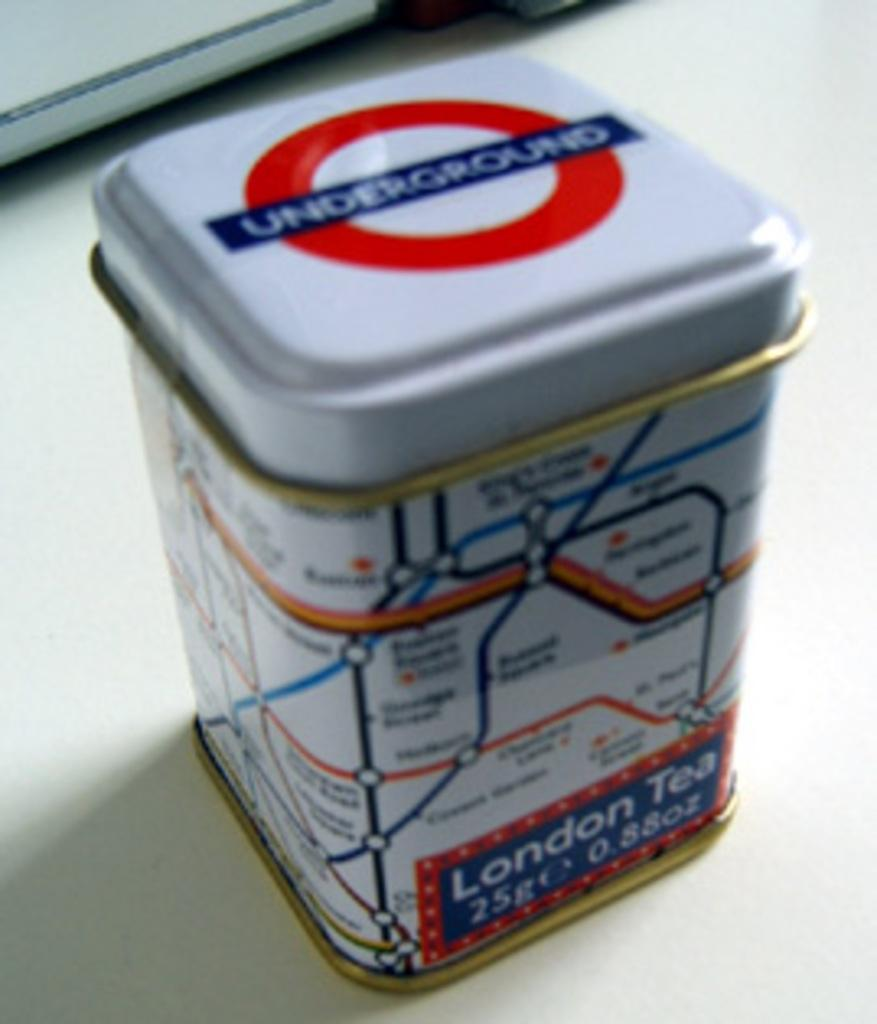<image>
Offer a succinct explanation of the picture presented. Small box showing a map and says "London Tea" on it. 